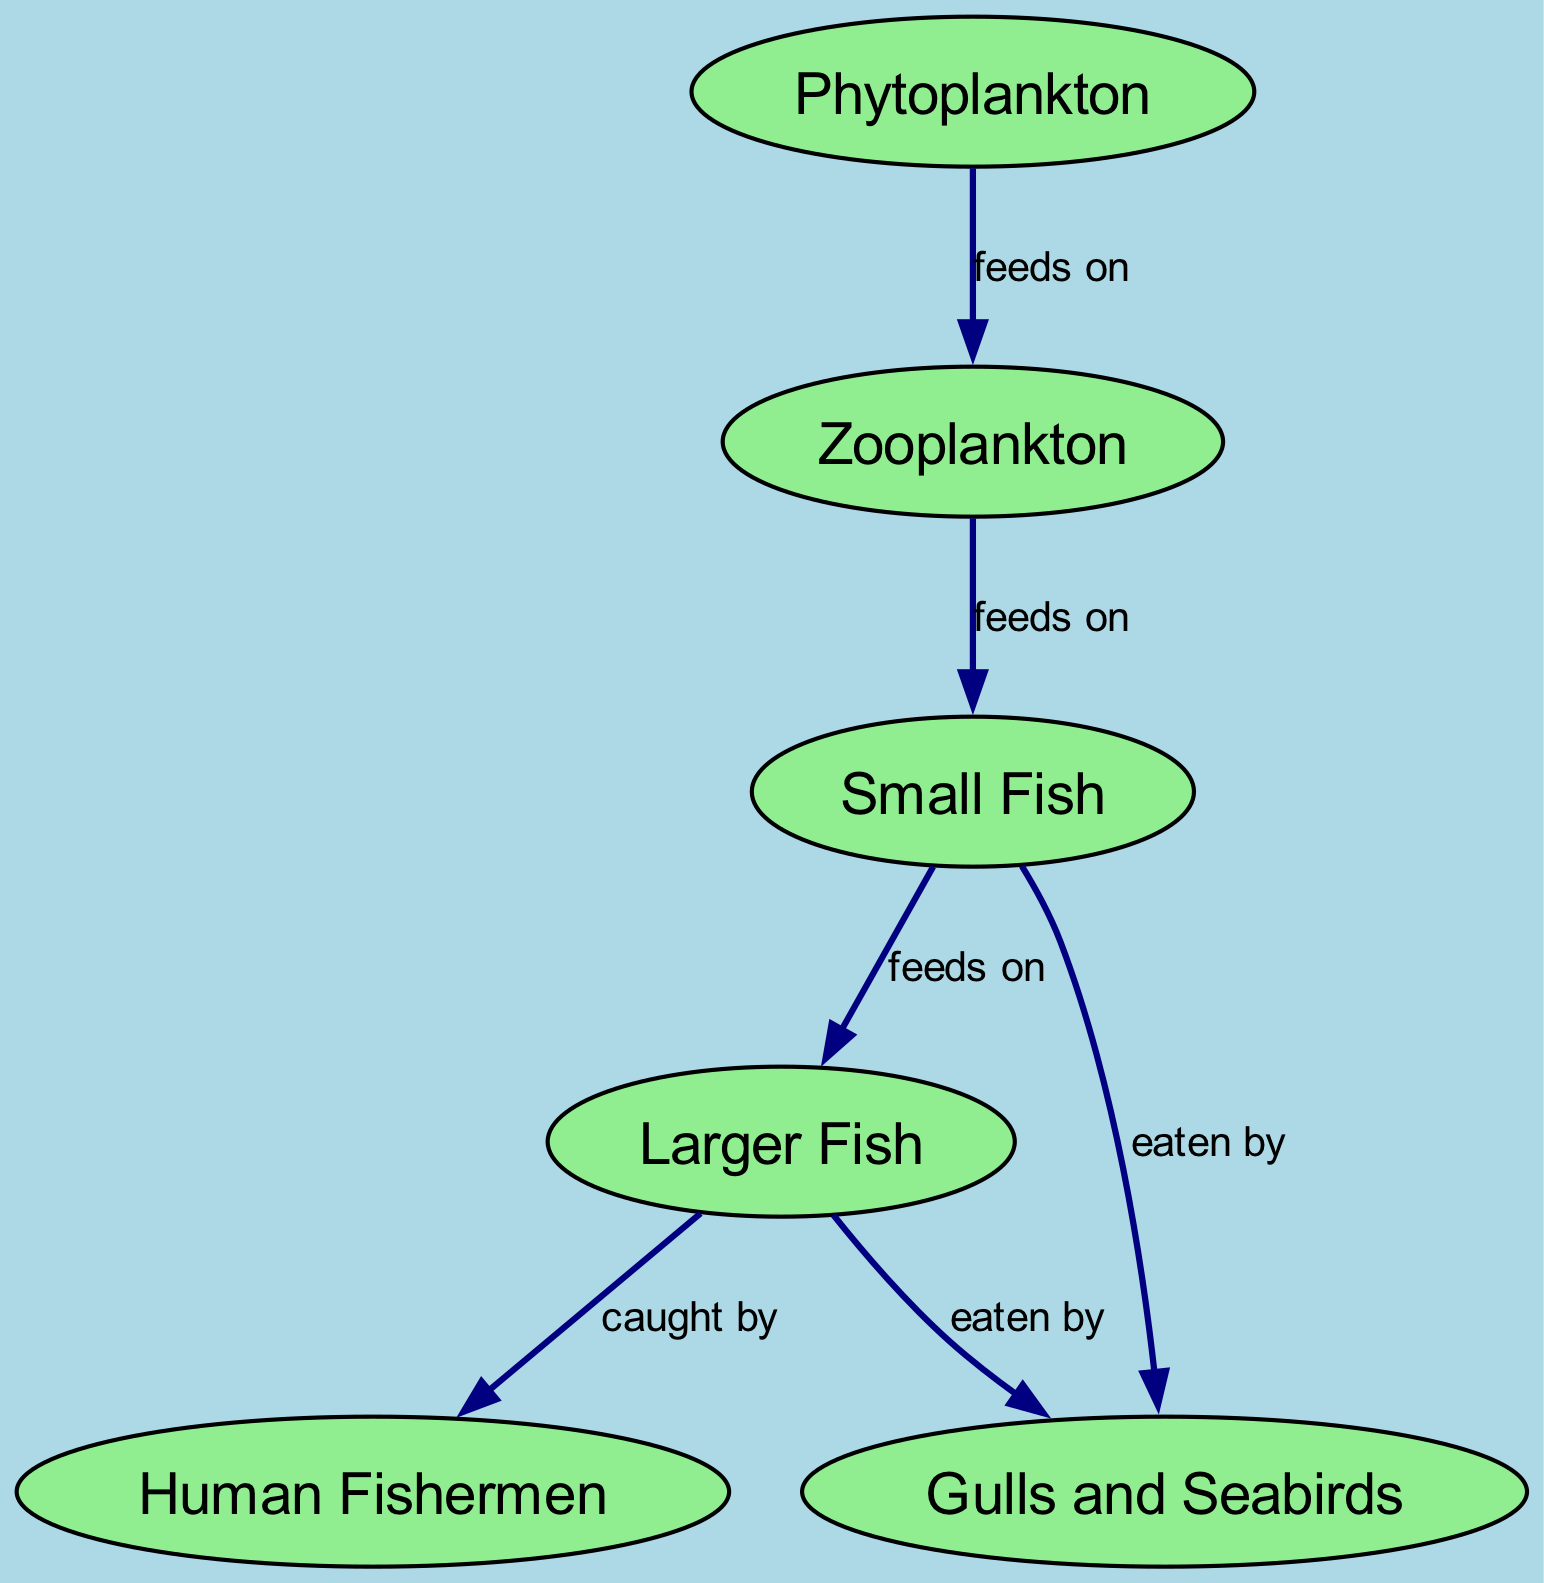What is the primary producer in the food chain? The diagram shows that phytoplankton is at the base of the food chain, making it the primary producer as it is responsible for photosynthesis and provides energy for the entire food web.
Answer: Phytoplankton How many nodes are present in the diagram? By counting the nodes visually or through the provided data, there are six distinct nodes represented in the food chain, indicating the different trophic levels or players involved.
Answer: Six Who feeds on zooplankton? The diagram indicates that small fish consume zooplankton, shown by the directed edge from zooplankton to small fish, which clarifies their position in the food chain as secondary consumers.
Answer: Small Fish What type of fishing practices do human fishermen engage in? The diagram states that human fishermen follow sustainable practices by adhering to quotas and using selective gear, highlighting their role in maintaining ecological balance.
Answer: Sustainable practices Which organisms are eaten by gulls and seabirds? The diagram illustrates that both small fish and larger fish are a food source for gulls and seabirds, as shown by the directed edges leading to the seabirds from these two groups.
Answer: Small Fish and Larger Fish What is the relationship between larger fish and human fishermen? The directed edge from larger fish to human fishermen indicates that larger fish are caught by human fishermen, showing their direct interaction and the effect of fishing activities on fish populations.
Answer: Caught by How many edges are present in the diagram? By analyzing the connections in the diagram, there are five edges displayed, representing the feeding relationships and interactions between the nodes.
Answer: Five What role do small fish play in the food chain? The diagram indicates that small fish are considered secondary consumers, as they feed on zooplankton and are also preyed upon by larger fish. This dual role emphasizes their importance in the energy transfer within the food web.
Answer: Secondary consumers What type of relationship exists between phytoplankton and zooplankton? The diagram specifies that the relationship is one of feeding, where phytoplankton serves as the food source for zooplankton, detailing the flow of energy from primary producers to the next level consumers.
Answer: Feeds on 